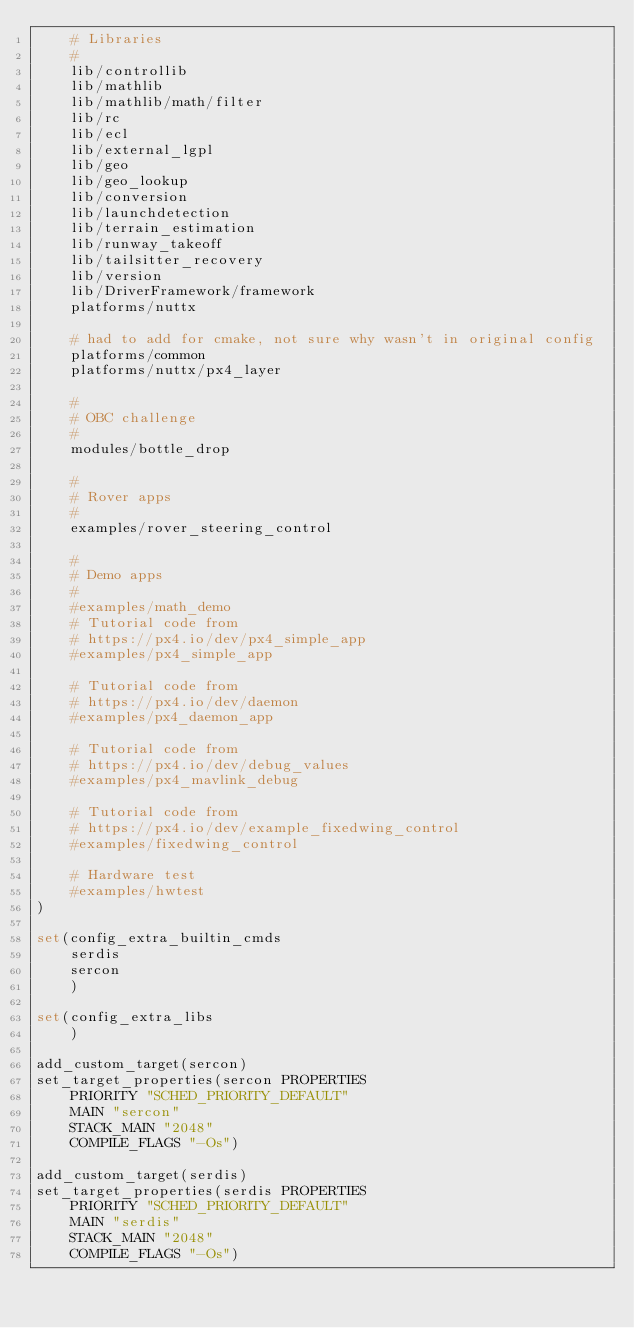<code> <loc_0><loc_0><loc_500><loc_500><_CMake_>	# Libraries
	#
	lib/controllib
	lib/mathlib
	lib/mathlib/math/filter
	lib/rc
	lib/ecl
	lib/external_lgpl
	lib/geo
	lib/geo_lookup
	lib/conversion
	lib/launchdetection
	lib/terrain_estimation
	lib/runway_takeoff
	lib/tailsitter_recovery
	lib/version
	lib/DriverFramework/framework
	platforms/nuttx

	# had to add for cmake, not sure why wasn't in original config
	platforms/common
	platforms/nuttx/px4_layer

	#
	# OBC challenge
	#
	modules/bottle_drop

	#
	# Rover apps
	#
	examples/rover_steering_control

	#
	# Demo apps
	#
	#examples/math_demo
	# Tutorial code from
	# https://px4.io/dev/px4_simple_app
	#examples/px4_simple_app

	# Tutorial code from
	# https://px4.io/dev/daemon
	#examples/px4_daemon_app

	# Tutorial code from
	# https://px4.io/dev/debug_values
	#examples/px4_mavlink_debug

	# Tutorial code from
	# https://px4.io/dev/example_fixedwing_control
	#examples/fixedwing_control

	# Hardware test
	#examples/hwtest
)

set(config_extra_builtin_cmds
	serdis
	sercon
	)

set(config_extra_libs
	)

add_custom_target(sercon)
set_target_properties(sercon PROPERTIES
	PRIORITY "SCHED_PRIORITY_DEFAULT"
	MAIN "sercon"
	STACK_MAIN "2048"
	COMPILE_FLAGS "-Os")

add_custom_target(serdis)
set_target_properties(serdis PROPERTIES
	PRIORITY "SCHED_PRIORITY_DEFAULT"
	MAIN "serdis"
	STACK_MAIN "2048"
	COMPILE_FLAGS "-Os")
</code> 